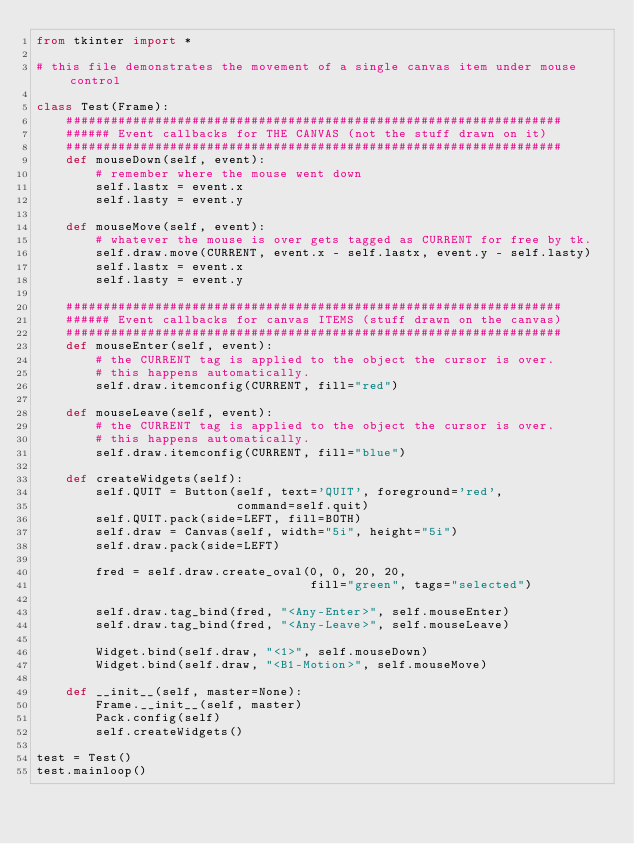Convert code to text. <code><loc_0><loc_0><loc_500><loc_500><_Python_>from tkinter import *

# this file demonstrates the movement of a single canvas item under mouse control

class Test(Frame):
    ###################################################################
    ###### Event callbacks for THE CANVAS (not the stuff drawn on it)
    ###################################################################
    def mouseDown(self, event):
        # remember where the mouse went down
        self.lastx = event.x
        self.lasty = event.y

    def mouseMove(self, event):
        # whatever the mouse is over gets tagged as CURRENT for free by tk.
        self.draw.move(CURRENT, event.x - self.lastx, event.y - self.lasty)
        self.lastx = event.x
        self.lasty = event.y

    ###################################################################
    ###### Event callbacks for canvas ITEMS (stuff drawn on the canvas)
    ###################################################################
    def mouseEnter(self, event):
        # the CURRENT tag is applied to the object the cursor is over.
        # this happens automatically.
        self.draw.itemconfig(CURRENT, fill="red")

    def mouseLeave(self, event):
        # the CURRENT tag is applied to the object the cursor is over.
        # this happens automatically.
        self.draw.itemconfig(CURRENT, fill="blue")

    def createWidgets(self):
        self.QUIT = Button(self, text='QUIT', foreground='red',
                           command=self.quit)
        self.QUIT.pack(side=LEFT, fill=BOTH)
        self.draw = Canvas(self, width="5i", height="5i")
        self.draw.pack(side=LEFT)

        fred = self.draw.create_oval(0, 0, 20, 20,
                                     fill="green", tags="selected")

        self.draw.tag_bind(fred, "<Any-Enter>", self.mouseEnter)
        self.draw.tag_bind(fred, "<Any-Leave>", self.mouseLeave)

        Widget.bind(self.draw, "<1>", self.mouseDown)
        Widget.bind(self.draw, "<B1-Motion>", self.mouseMove)

    def __init__(self, master=None):
        Frame.__init__(self, master)
        Pack.config(self)
        self.createWidgets()

test = Test()
test.mainloop()
</code> 